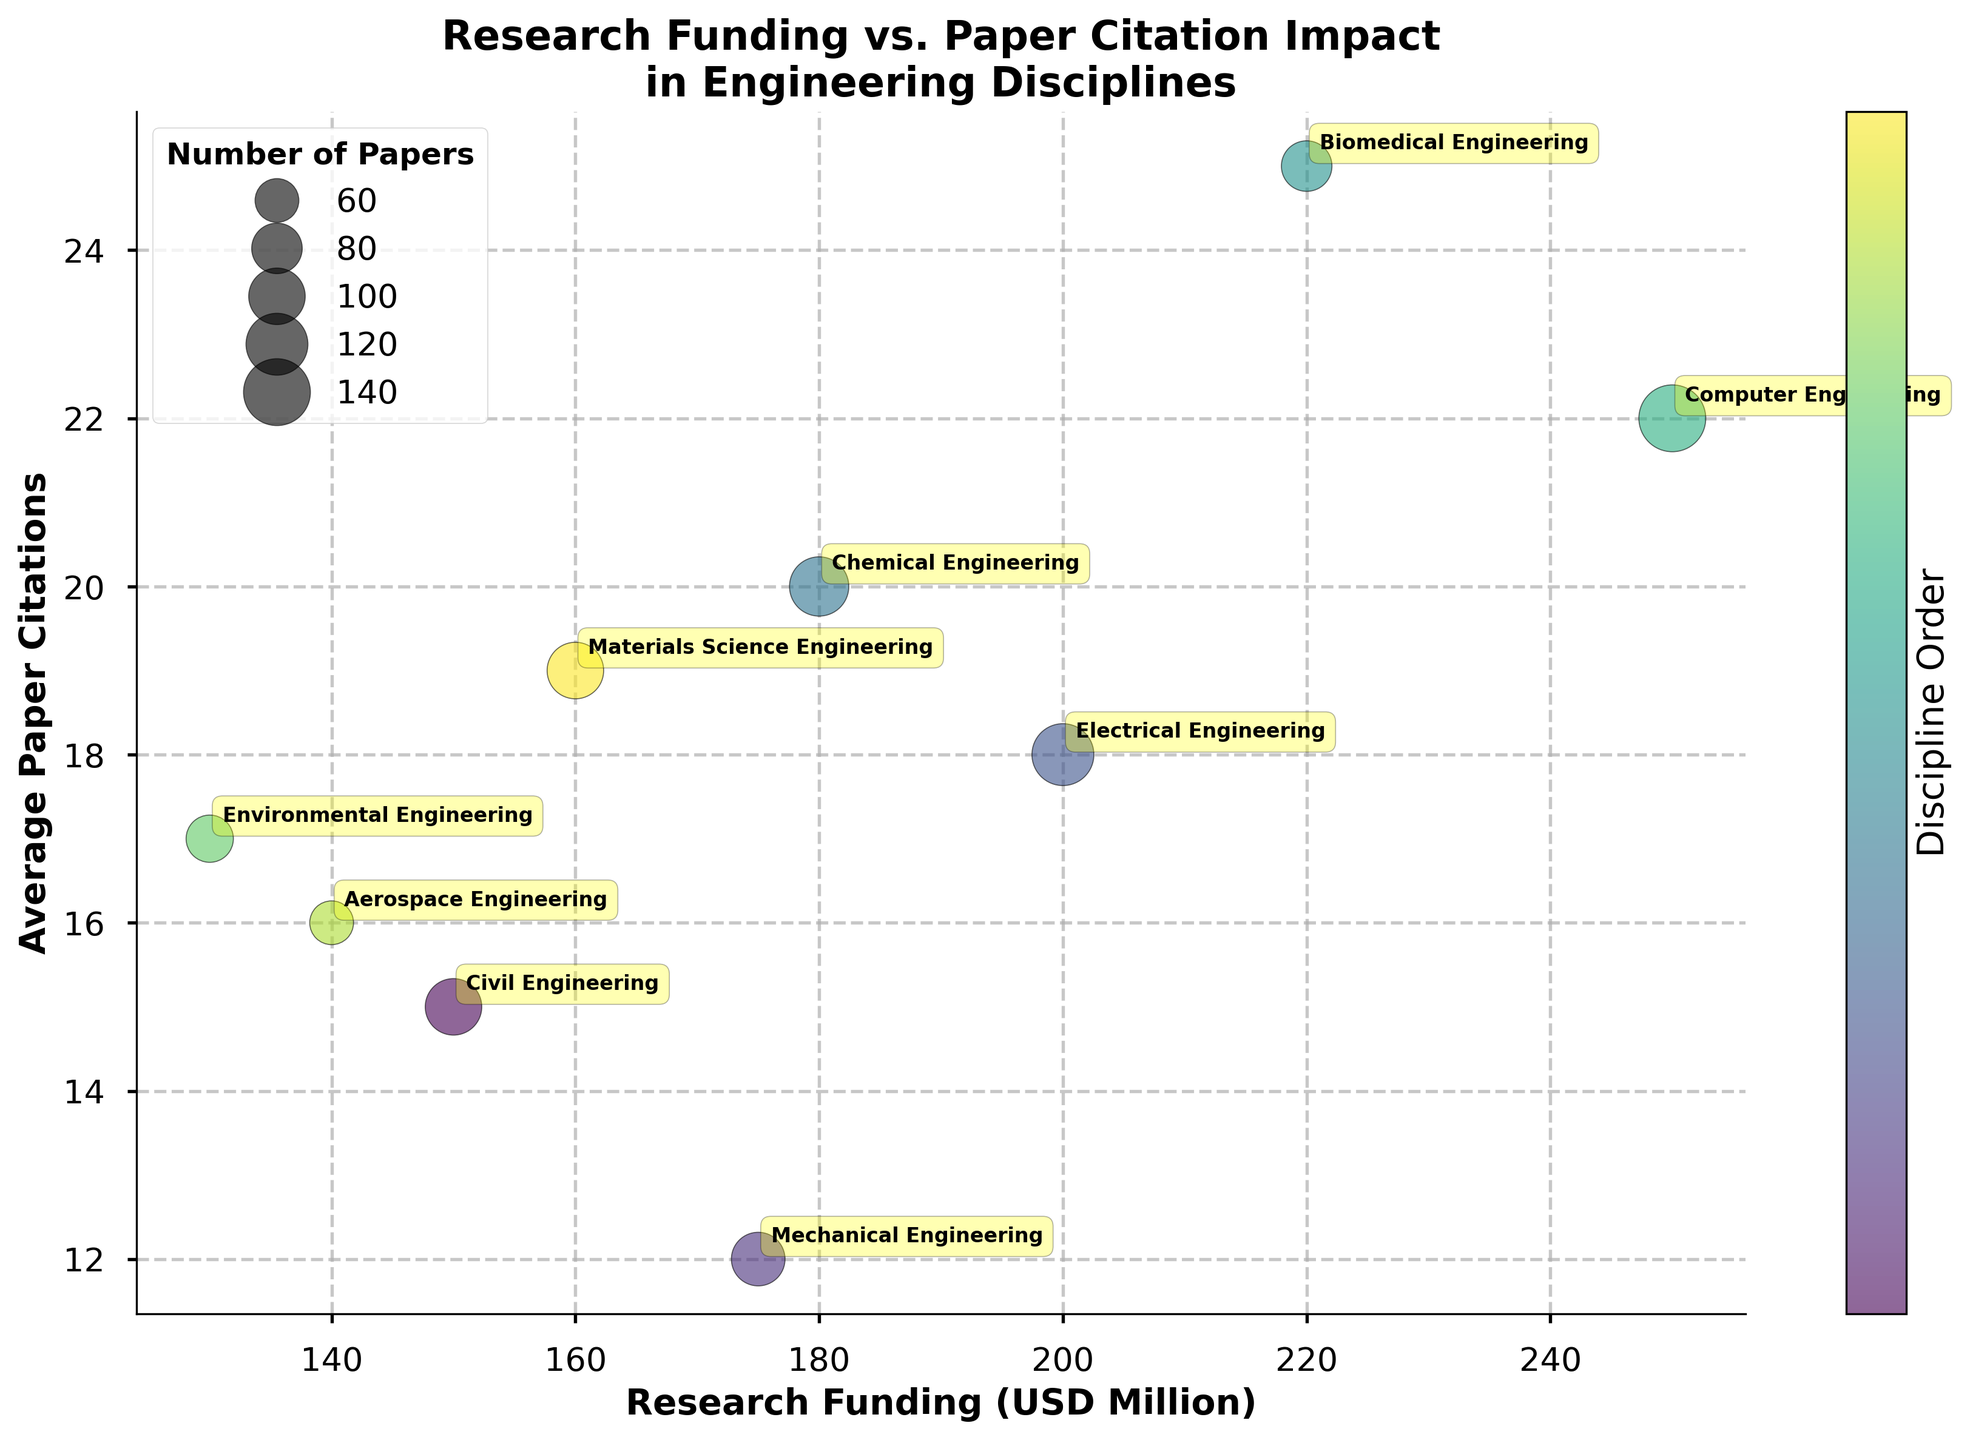what is the title of the chart? The title of the chart is displayed at the top of the figure, indicating the subject of the data visualization. The title reads "Research Funding vs. Paper Citation Impact in Engineering Disciplines".
Answer: Research Funding vs. Paper Citation Impact in Engineering Disciplines Which engineering discipline has the highest research funding? By looking at the x-axis (Research Funding in USD Million), the data point furthest to the right corresponds to Computer Engineering, which has a research funding of 250 million USD.
Answer: Computer Engineering What is the average paper citation for Environmental Engineering? The y-axis represents the Average Paper Citations, and the data point for Environmental Engineering is positioned at 17 citations.
Answer: 17 What's the difference in average paper citations between Chemical Engineering and Civil Engineering? The y-axis shows the average paper citations. Chemical Engineering has 20 citations, while Civil Engineering has 15 citations. The difference is calculated as 20 - 15.
Answer: 5 What's the sum of the number of papers in Mechanical Engineering and Biomedical Engineering? The bubble size indicates the number of papers. Mechanical Engineering has 450 papers, and Biomedical Engineering has 400 papers. The sum is 450 + 400.
Answer: 850 Which discipline has more average paper citations, Electrical Engineering or Aerospace Engineering? Electrical Engineering has an average of 18 citations, while Aerospace Engineering has 16 citations. Therefore, Electrical Engineering has more citations.
Answer: Electrical Engineering Compare the research funding between Material Science Engineering and Civil Engineering. Which one has greater funding? Material Science Engineering has a funding of 160 million USD, while Civil Engineering has 150 million USD. Material Science Engineering has greater funding.
Answer: Material Science Engineering Which discipline has the smallest bubble size? What does this signify? Environmental Engineering has the smallest bubble size, indicating it has the least number of papers, which is 350.
Answer: Environmental Engineering What's the rank order of research funding from highest to lowest for Biomedical Engineering, Mechanical Engineering, and Civil Engineering? Biomedical Engineering has 220 million USD, Mechanical Engineering has 175 million USD, and Civil Engineering has 150 million USD. The order from highest to lowest is Biomedical Engineering, Mechanical Engineering, Civil Engineering.
Answer: Biomedical Engineering, Mechanical Engineering, Civil Engineering 